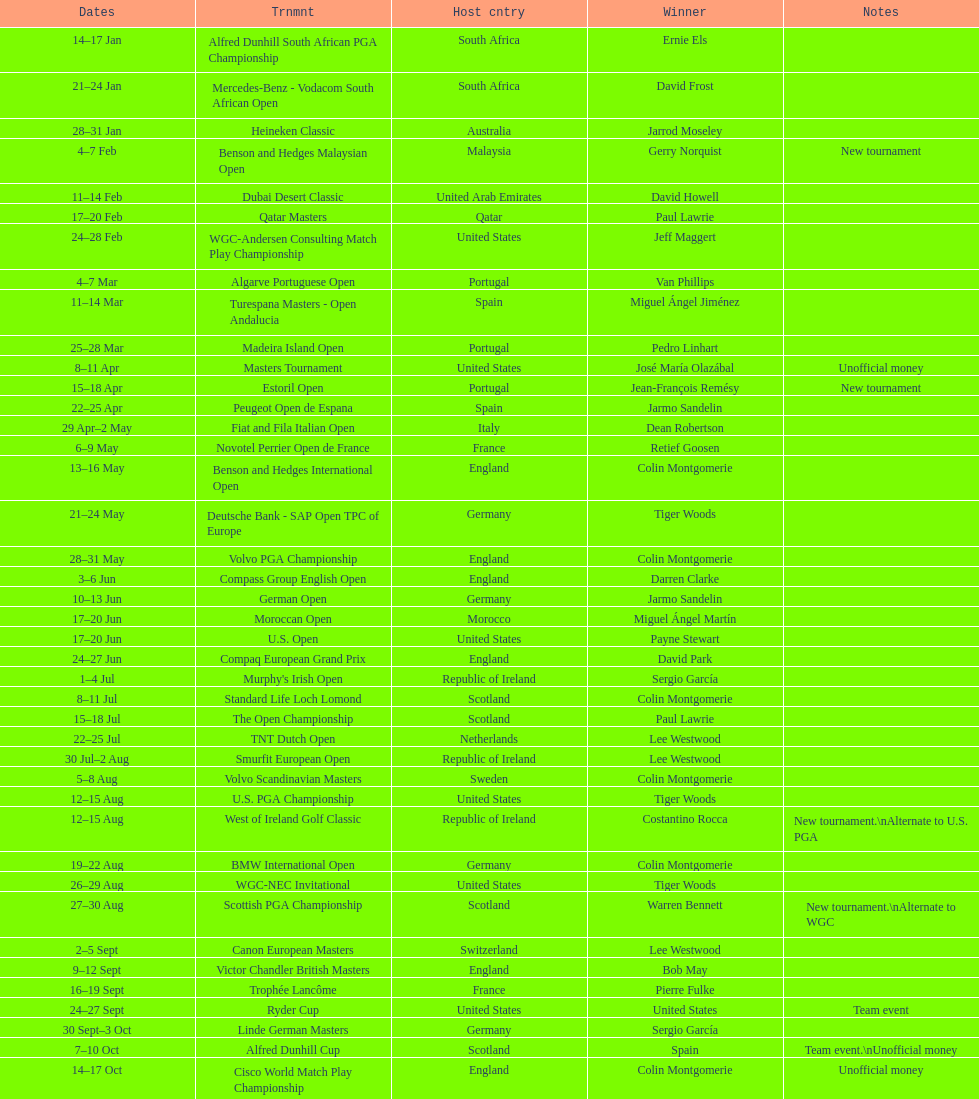How many tournaments began before aug 15th 31. 